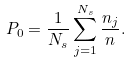Convert formula to latex. <formula><loc_0><loc_0><loc_500><loc_500>P _ { 0 } = \frac { 1 } { N _ { s } } \sum _ { j = 1 } ^ { N _ { s } } \frac { n _ { j } } { n } .</formula> 